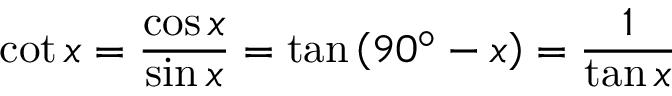<formula> <loc_0><loc_0><loc_500><loc_500>\cot x = { \frac { \cos x } { \sin x } } = \tan \left ( 9 0 ^ { \circ } - x \right ) = { \frac { 1 } { \tan x } }</formula> 